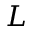<formula> <loc_0><loc_0><loc_500><loc_500>L</formula> 